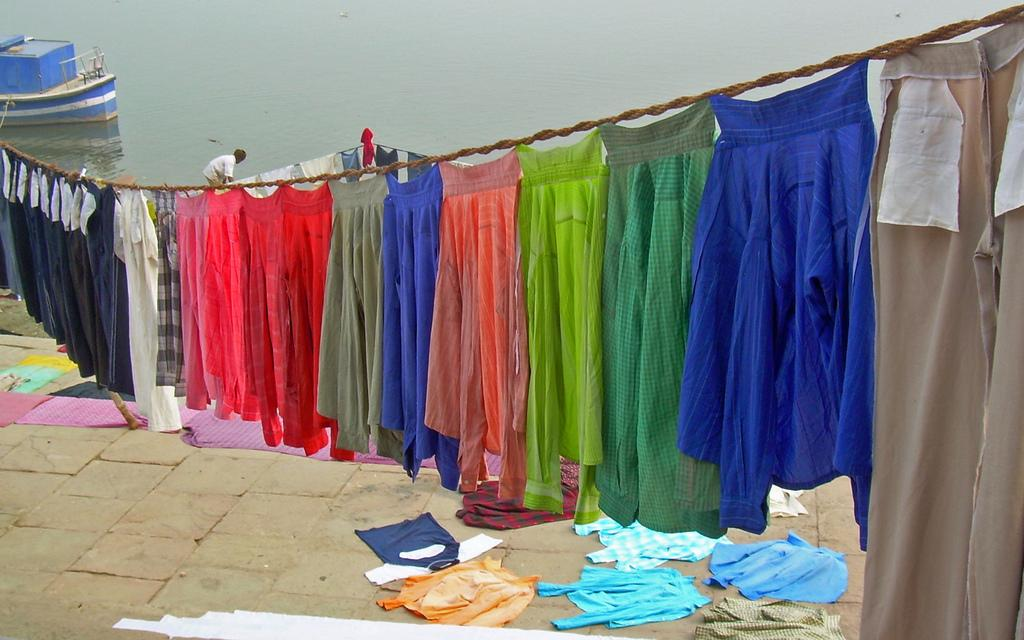What is being hung on the rope in the image? There are clothes hanging on a rope in the image. What is the person in the image doing? The person is in the water on the left side of the image. What type of watercraft is present in the image? There is a blue boat in the image. What type of chain is being used to hold the boat in the image? There is no chain present in the image; the boat is held by a rope. What is the friction between the person and the water in the image? The question about friction is not relevant to the image, as friction is a concept related to the force between two surfaces in contact, and there is no information provided about the person's interaction with the water. 